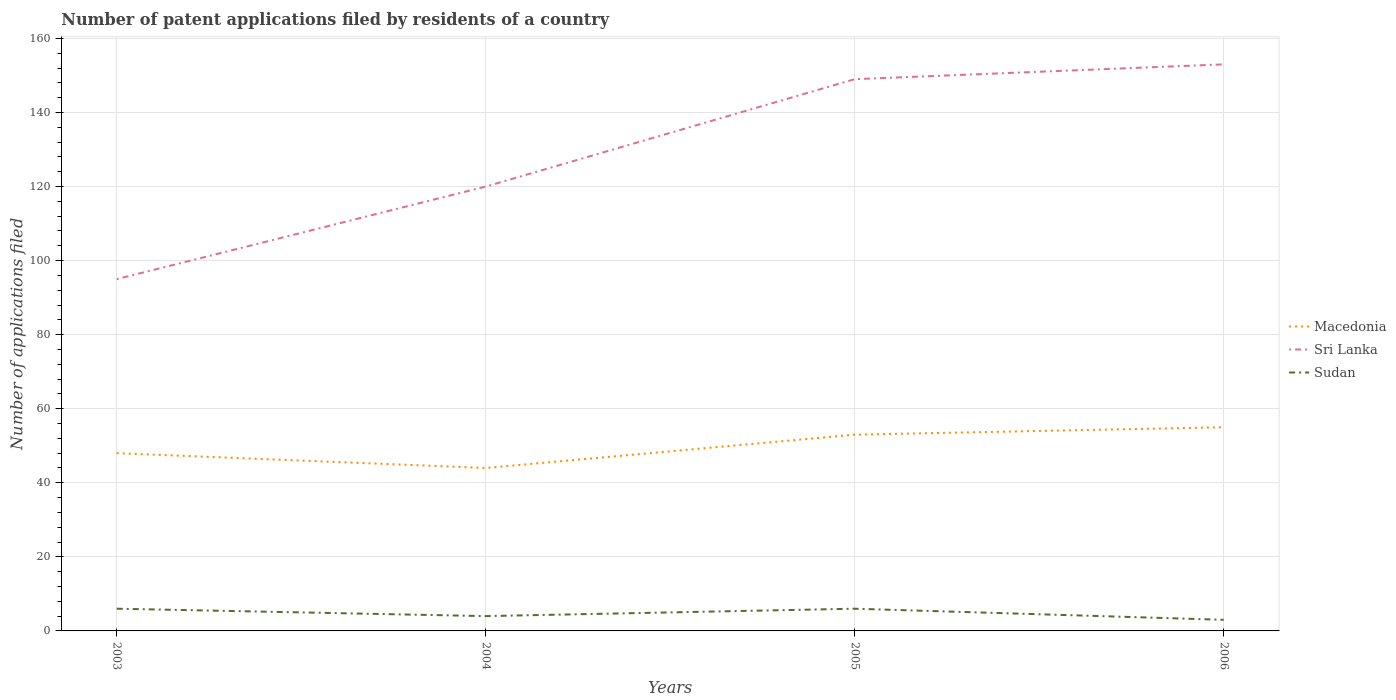Is the number of lines equal to the number of legend labels?
Offer a very short reply. Yes. Across all years, what is the maximum number of applications filed in Sudan?
Your response must be concise. 3. In which year was the number of applications filed in Sudan maximum?
Your answer should be compact. 2006. What is the total number of applications filed in Sri Lanka in the graph?
Ensure brevity in your answer.  -58. What is the difference between the highest and the second highest number of applications filed in Sri Lanka?
Keep it short and to the point. 58. What is the difference between the highest and the lowest number of applications filed in Sudan?
Give a very brief answer. 2. How many lines are there?
Provide a succinct answer. 3. Does the graph contain grids?
Offer a very short reply. Yes. Where does the legend appear in the graph?
Make the answer very short. Center right. How many legend labels are there?
Ensure brevity in your answer.  3. How are the legend labels stacked?
Offer a very short reply. Vertical. What is the title of the graph?
Offer a terse response. Number of patent applications filed by residents of a country. Does "North America" appear as one of the legend labels in the graph?
Provide a short and direct response. No. What is the label or title of the Y-axis?
Your answer should be compact. Number of applications filed. What is the Number of applications filed of Sudan in 2003?
Your answer should be very brief. 6. What is the Number of applications filed of Macedonia in 2004?
Give a very brief answer. 44. What is the Number of applications filed in Sri Lanka in 2004?
Keep it short and to the point. 120. What is the Number of applications filed in Sudan in 2004?
Make the answer very short. 4. What is the Number of applications filed of Sri Lanka in 2005?
Your answer should be very brief. 149. What is the Number of applications filed in Sudan in 2005?
Offer a very short reply. 6. What is the Number of applications filed of Macedonia in 2006?
Ensure brevity in your answer.  55. What is the Number of applications filed of Sri Lanka in 2006?
Offer a terse response. 153. What is the Number of applications filed in Sudan in 2006?
Give a very brief answer. 3. Across all years, what is the maximum Number of applications filed of Macedonia?
Your response must be concise. 55. Across all years, what is the maximum Number of applications filed in Sri Lanka?
Your answer should be compact. 153. Across all years, what is the maximum Number of applications filed of Sudan?
Your answer should be very brief. 6. Across all years, what is the minimum Number of applications filed in Macedonia?
Give a very brief answer. 44. What is the total Number of applications filed of Macedonia in the graph?
Ensure brevity in your answer.  200. What is the total Number of applications filed of Sri Lanka in the graph?
Your answer should be compact. 517. What is the total Number of applications filed of Sudan in the graph?
Give a very brief answer. 19. What is the difference between the Number of applications filed in Sri Lanka in 2003 and that in 2004?
Offer a terse response. -25. What is the difference between the Number of applications filed of Sudan in 2003 and that in 2004?
Keep it short and to the point. 2. What is the difference between the Number of applications filed of Macedonia in 2003 and that in 2005?
Keep it short and to the point. -5. What is the difference between the Number of applications filed of Sri Lanka in 2003 and that in 2005?
Your answer should be very brief. -54. What is the difference between the Number of applications filed of Macedonia in 2003 and that in 2006?
Ensure brevity in your answer.  -7. What is the difference between the Number of applications filed of Sri Lanka in 2003 and that in 2006?
Offer a terse response. -58. What is the difference between the Number of applications filed in Sri Lanka in 2004 and that in 2005?
Offer a terse response. -29. What is the difference between the Number of applications filed in Sudan in 2004 and that in 2005?
Offer a very short reply. -2. What is the difference between the Number of applications filed in Macedonia in 2004 and that in 2006?
Offer a very short reply. -11. What is the difference between the Number of applications filed of Sri Lanka in 2004 and that in 2006?
Offer a very short reply. -33. What is the difference between the Number of applications filed of Macedonia in 2005 and that in 2006?
Your response must be concise. -2. What is the difference between the Number of applications filed of Sri Lanka in 2005 and that in 2006?
Offer a terse response. -4. What is the difference between the Number of applications filed in Macedonia in 2003 and the Number of applications filed in Sri Lanka in 2004?
Offer a terse response. -72. What is the difference between the Number of applications filed of Macedonia in 2003 and the Number of applications filed of Sudan in 2004?
Your response must be concise. 44. What is the difference between the Number of applications filed in Sri Lanka in 2003 and the Number of applications filed in Sudan in 2004?
Your answer should be very brief. 91. What is the difference between the Number of applications filed in Macedonia in 2003 and the Number of applications filed in Sri Lanka in 2005?
Ensure brevity in your answer.  -101. What is the difference between the Number of applications filed of Macedonia in 2003 and the Number of applications filed of Sudan in 2005?
Make the answer very short. 42. What is the difference between the Number of applications filed in Sri Lanka in 2003 and the Number of applications filed in Sudan in 2005?
Your answer should be compact. 89. What is the difference between the Number of applications filed in Macedonia in 2003 and the Number of applications filed in Sri Lanka in 2006?
Offer a very short reply. -105. What is the difference between the Number of applications filed of Macedonia in 2003 and the Number of applications filed of Sudan in 2006?
Ensure brevity in your answer.  45. What is the difference between the Number of applications filed of Sri Lanka in 2003 and the Number of applications filed of Sudan in 2006?
Ensure brevity in your answer.  92. What is the difference between the Number of applications filed of Macedonia in 2004 and the Number of applications filed of Sri Lanka in 2005?
Make the answer very short. -105. What is the difference between the Number of applications filed of Macedonia in 2004 and the Number of applications filed of Sudan in 2005?
Provide a succinct answer. 38. What is the difference between the Number of applications filed in Sri Lanka in 2004 and the Number of applications filed in Sudan in 2005?
Offer a very short reply. 114. What is the difference between the Number of applications filed in Macedonia in 2004 and the Number of applications filed in Sri Lanka in 2006?
Ensure brevity in your answer.  -109. What is the difference between the Number of applications filed in Macedonia in 2004 and the Number of applications filed in Sudan in 2006?
Give a very brief answer. 41. What is the difference between the Number of applications filed in Sri Lanka in 2004 and the Number of applications filed in Sudan in 2006?
Keep it short and to the point. 117. What is the difference between the Number of applications filed in Macedonia in 2005 and the Number of applications filed in Sri Lanka in 2006?
Your answer should be very brief. -100. What is the difference between the Number of applications filed in Macedonia in 2005 and the Number of applications filed in Sudan in 2006?
Your response must be concise. 50. What is the difference between the Number of applications filed in Sri Lanka in 2005 and the Number of applications filed in Sudan in 2006?
Provide a succinct answer. 146. What is the average Number of applications filed in Sri Lanka per year?
Offer a terse response. 129.25. What is the average Number of applications filed of Sudan per year?
Your answer should be compact. 4.75. In the year 2003, what is the difference between the Number of applications filed of Macedonia and Number of applications filed of Sri Lanka?
Your answer should be very brief. -47. In the year 2003, what is the difference between the Number of applications filed in Macedonia and Number of applications filed in Sudan?
Keep it short and to the point. 42. In the year 2003, what is the difference between the Number of applications filed of Sri Lanka and Number of applications filed of Sudan?
Keep it short and to the point. 89. In the year 2004, what is the difference between the Number of applications filed in Macedonia and Number of applications filed in Sri Lanka?
Your response must be concise. -76. In the year 2004, what is the difference between the Number of applications filed in Sri Lanka and Number of applications filed in Sudan?
Keep it short and to the point. 116. In the year 2005, what is the difference between the Number of applications filed of Macedonia and Number of applications filed of Sri Lanka?
Give a very brief answer. -96. In the year 2005, what is the difference between the Number of applications filed of Sri Lanka and Number of applications filed of Sudan?
Keep it short and to the point. 143. In the year 2006, what is the difference between the Number of applications filed of Macedonia and Number of applications filed of Sri Lanka?
Give a very brief answer. -98. In the year 2006, what is the difference between the Number of applications filed of Sri Lanka and Number of applications filed of Sudan?
Offer a terse response. 150. What is the ratio of the Number of applications filed of Macedonia in 2003 to that in 2004?
Your response must be concise. 1.09. What is the ratio of the Number of applications filed in Sri Lanka in 2003 to that in 2004?
Provide a short and direct response. 0.79. What is the ratio of the Number of applications filed in Macedonia in 2003 to that in 2005?
Provide a succinct answer. 0.91. What is the ratio of the Number of applications filed in Sri Lanka in 2003 to that in 2005?
Offer a terse response. 0.64. What is the ratio of the Number of applications filed of Sudan in 2003 to that in 2005?
Give a very brief answer. 1. What is the ratio of the Number of applications filed of Macedonia in 2003 to that in 2006?
Provide a succinct answer. 0.87. What is the ratio of the Number of applications filed of Sri Lanka in 2003 to that in 2006?
Your response must be concise. 0.62. What is the ratio of the Number of applications filed in Sudan in 2003 to that in 2006?
Offer a very short reply. 2. What is the ratio of the Number of applications filed of Macedonia in 2004 to that in 2005?
Provide a succinct answer. 0.83. What is the ratio of the Number of applications filed in Sri Lanka in 2004 to that in 2005?
Ensure brevity in your answer.  0.81. What is the ratio of the Number of applications filed of Sudan in 2004 to that in 2005?
Offer a terse response. 0.67. What is the ratio of the Number of applications filed of Macedonia in 2004 to that in 2006?
Offer a terse response. 0.8. What is the ratio of the Number of applications filed of Sri Lanka in 2004 to that in 2006?
Make the answer very short. 0.78. What is the ratio of the Number of applications filed in Macedonia in 2005 to that in 2006?
Keep it short and to the point. 0.96. What is the ratio of the Number of applications filed of Sri Lanka in 2005 to that in 2006?
Provide a short and direct response. 0.97. What is the ratio of the Number of applications filed in Sudan in 2005 to that in 2006?
Offer a very short reply. 2. What is the difference between the highest and the second highest Number of applications filed in Macedonia?
Keep it short and to the point. 2. What is the difference between the highest and the lowest Number of applications filed in Macedonia?
Provide a succinct answer. 11. What is the difference between the highest and the lowest Number of applications filed in Sri Lanka?
Offer a terse response. 58. 